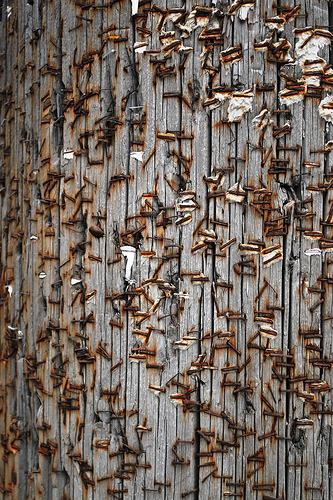<image>
Can you confirm if the staple is on the wood? Yes. Looking at the image, I can see the staple is positioned on top of the wood, with the wood providing support. 